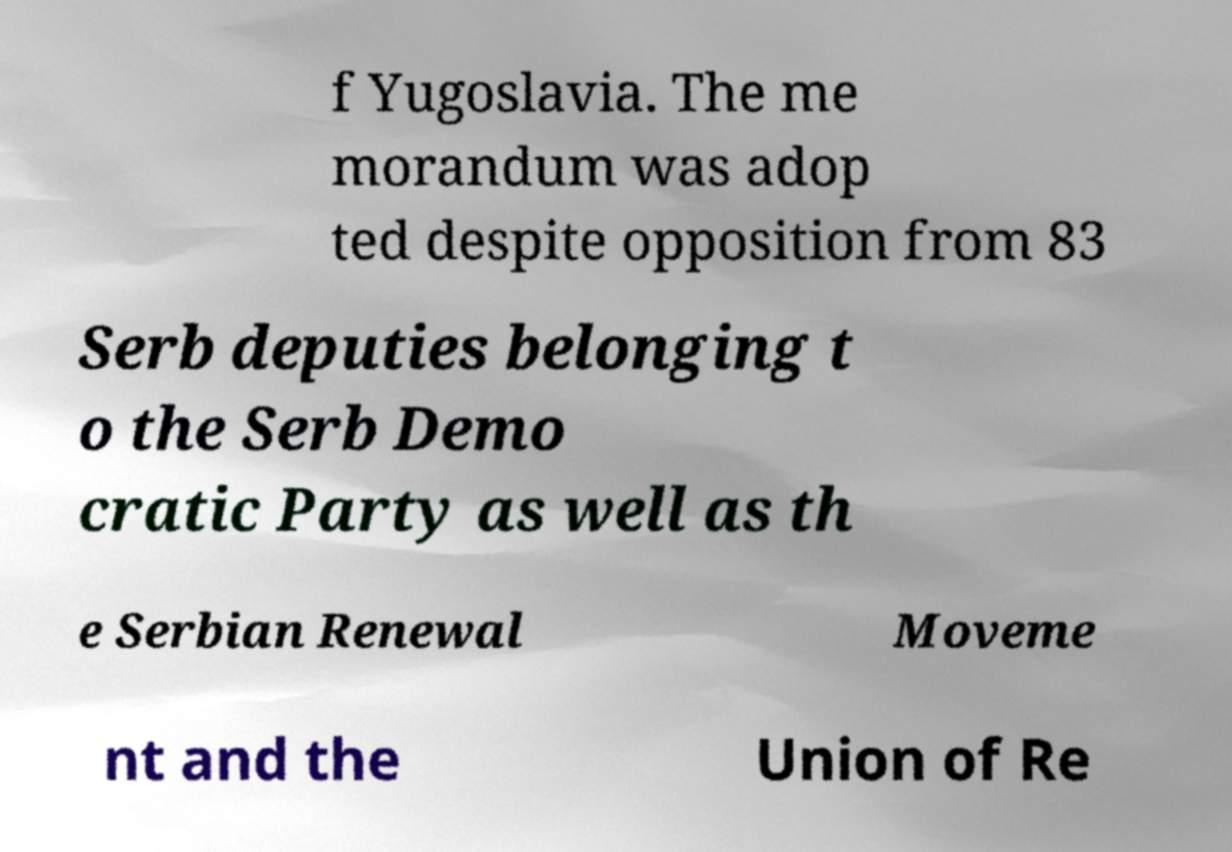Can you accurately transcribe the text from the provided image for me? f Yugoslavia. The me morandum was adop ted despite opposition from 83 Serb deputies belonging t o the Serb Demo cratic Party as well as th e Serbian Renewal Moveme nt and the Union of Re 